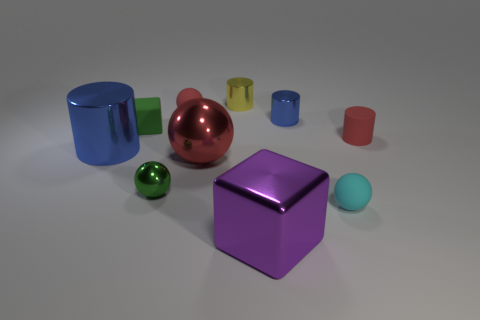Is there a tiny object?
Offer a terse response. Yes. What is the color of the large thing that is to the left of the small red rubber object behind the red matte cylinder?
Provide a succinct answer. Blue. What number of other objects are the same color as the matte cube?
Provide a succinct answer. 1. What number of objects are either large red spheres or shiny objects that are to the right of the big blue metal thing?
Offer a very short reply. 5. The small thing that is to the left of the small green sphere is what color?
Ensure brevity in your answer.  Green. What is the shape of the tiny green rubber object?
Give a very brief answer. Cube. The red ball that is behind the green object behind the red metallic sphere is made of what material?
Offer a very short reply. Rubber. How many other things are there of the same material as the green cube?
Offer a very short reply. 3. There is a cylinder that is the same size as the red metallic ball; what is its material?
Give a very brief answer. Metal. Are there more large blue cylinders to the left of the yellow cylinder than big shiny cubes on the left side of the tiny green rubber block?
Provide a short and direct response. Yes. 